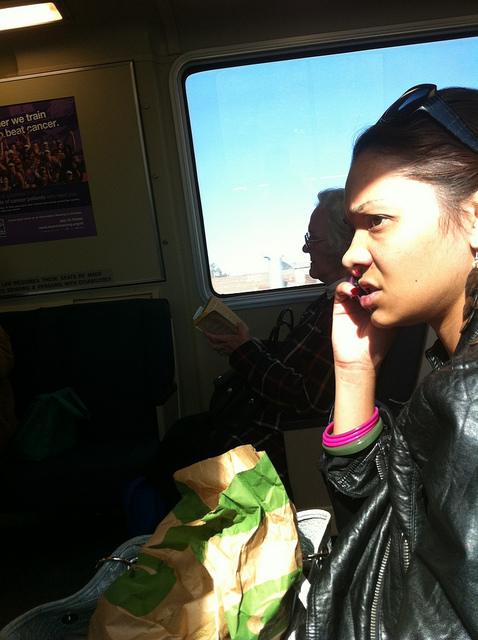Identify and read out the text in this image. we beat train cancer 